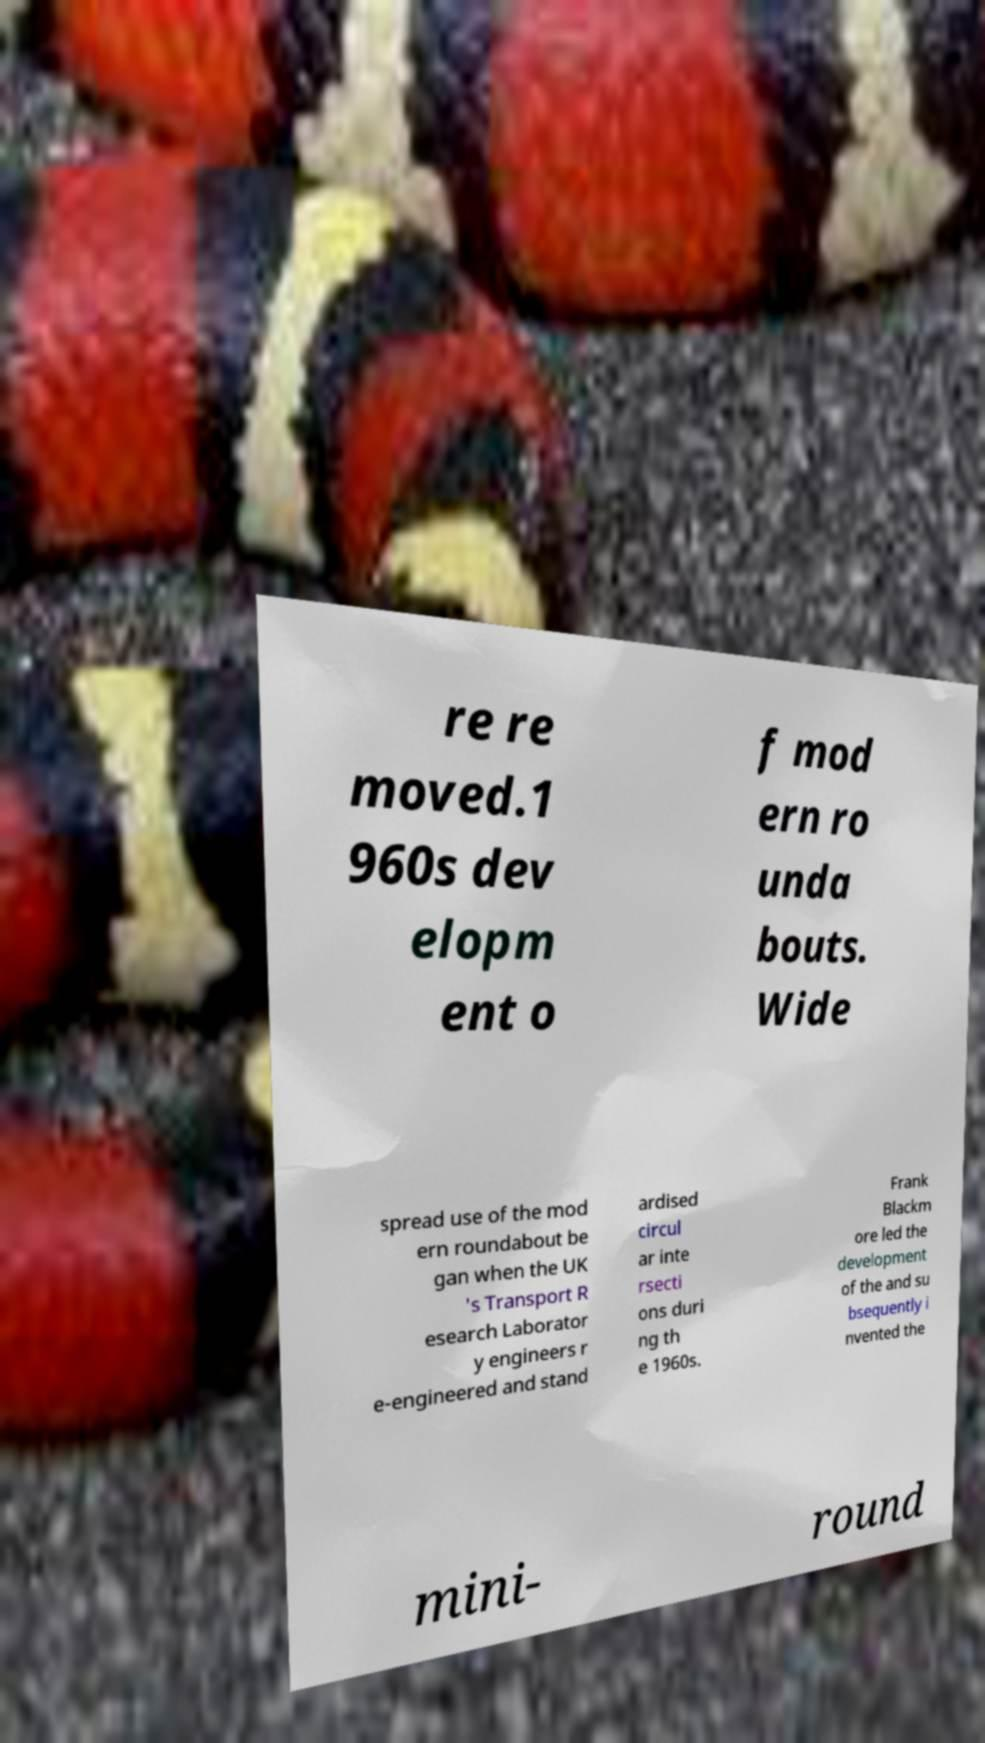I need the written content from this picture converted into text. Can you do that? re re moved.1 960s dev elopm ent o f mod ern ro unda bouts. Wide spread use of the mod ern roundabout be gan when the UK 's Transport R esearch Laborator y engineers r e-engineered and stand ardised circul ar inte rsecti ons duri ng th e 1960s. Frank Blackm ore led the development of the and su bsequently i nvented the mini- round 